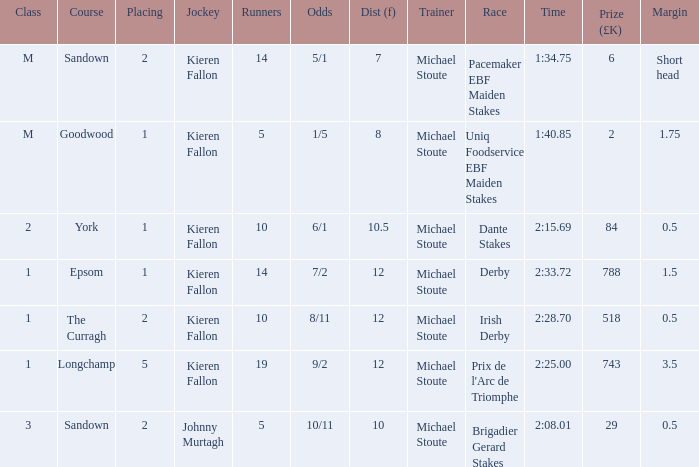Name the least runners with dist of 10.5 10.0. 